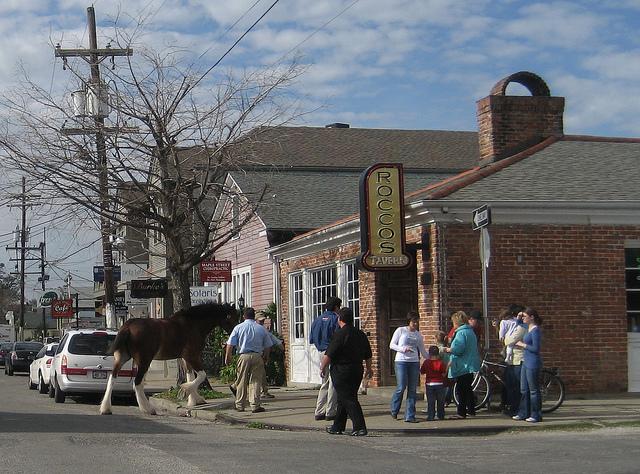What color is the man's shirt?
Short answer required. Black. Is this house most likely located in the country or in the city?
Give a very brief answer. Country. What church is this?
Answer briefly. Rocco's. Who is riding the horses?
Concise answer only. No one. Is this picture recent?
Be succinct. Yes. Is this building more than 5 stories tall?
Short answer required. No. What is the name on the building?
Concise answer only. Rocco's. What is the horse doing?
Quick response, please. Walking. Are the people waiting for a bus?
Concise answer only. No. What color is the center building?
Answer briefly. Red. Is the guy on a sidewalk?
Short answer required. Yes. Are the people running away?
Give a very brief answer. No. Are the people tourists?
Give a very brief answer. No. Is this a recent photo?
Answer briefly. Yes. What was the sexual orientation of the person that designed parking area of this building?
Concise answer only. Heterosexual. Are there any people on the street?
Answer briefly. Yes. Are these kids walking home?
Write a very short answer. No. What color is the truck?
Be succinct. White. How many women are here?
Give a very brief answer. 6. What are the cylindrical objects attached to the telephone polls?
Quick response, please. Transformers. Do you see a mailbox?
Keep it brief. No. 